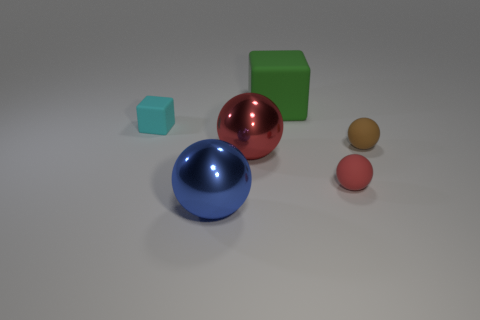There is a big rubber object; is its shape the same as the tiny matte object that is in front of the brown rubber ball?
Ensure brevity in your answer.  No. There is a small thing that is both on the right side of the blue thing and to the left of the brown matte ball; what is its color?
Provide a short and direct response. Red. Is there a cyan cube?
Make the answer very short. Yes. Are there the same number of cyan rubber things right of the red shiny thing and matte balls?
Offer a very short reply. No. How many other objects are there of the same shape as the big red thing?
Keep it short and to the point. 3. What shape is the large red thing?
Your response must be concise. Sphere. Does the tiny cube have the same material as the brown object?
Keep it short and to the point. Yes. Are there the same number of tiny objects in front of the blue thing and large blue balls that are on the right side of the tiny red rubber object?
Make the answer very short. Yes. There is a red thing that is in front of the shiny object that is on the right side of the large blue ball; is there a tiny red object behind it?
Provide a succinct answer. No. Do the brown rubber ball and the red metal ball have the same size?
Your response must be concise. No. 